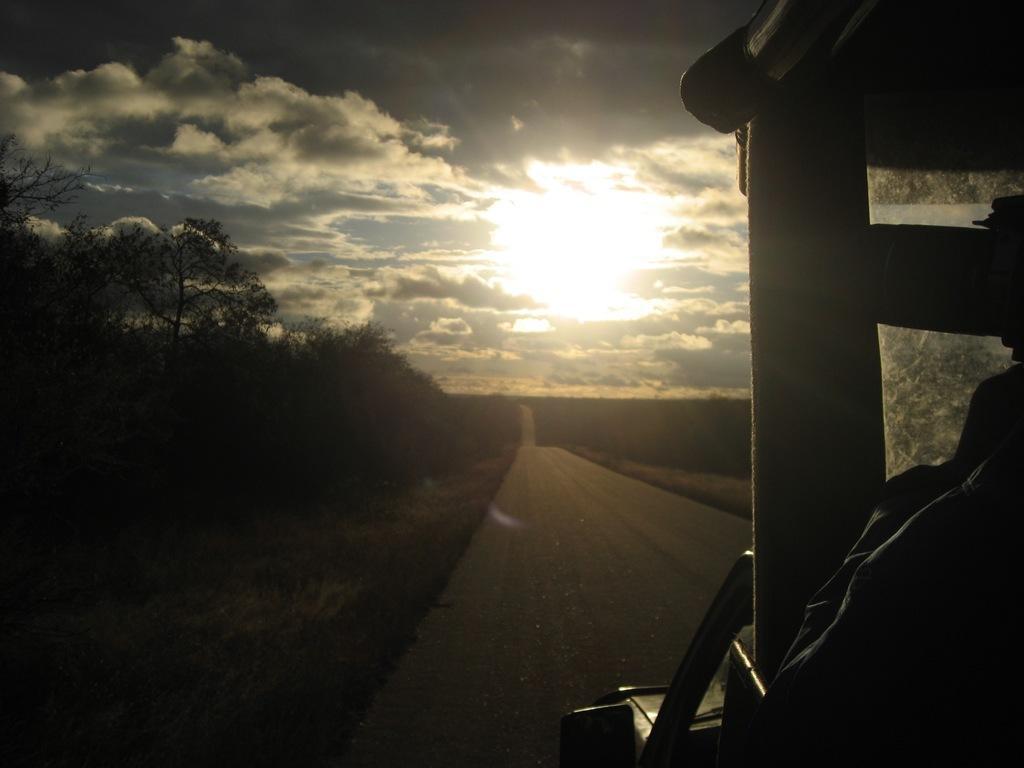Describe this image in one or two sentences. In this image we can see trees, road, grass and other objects. At the top of the image there is the sky. On the right side of the image it looks like a vehicle. 